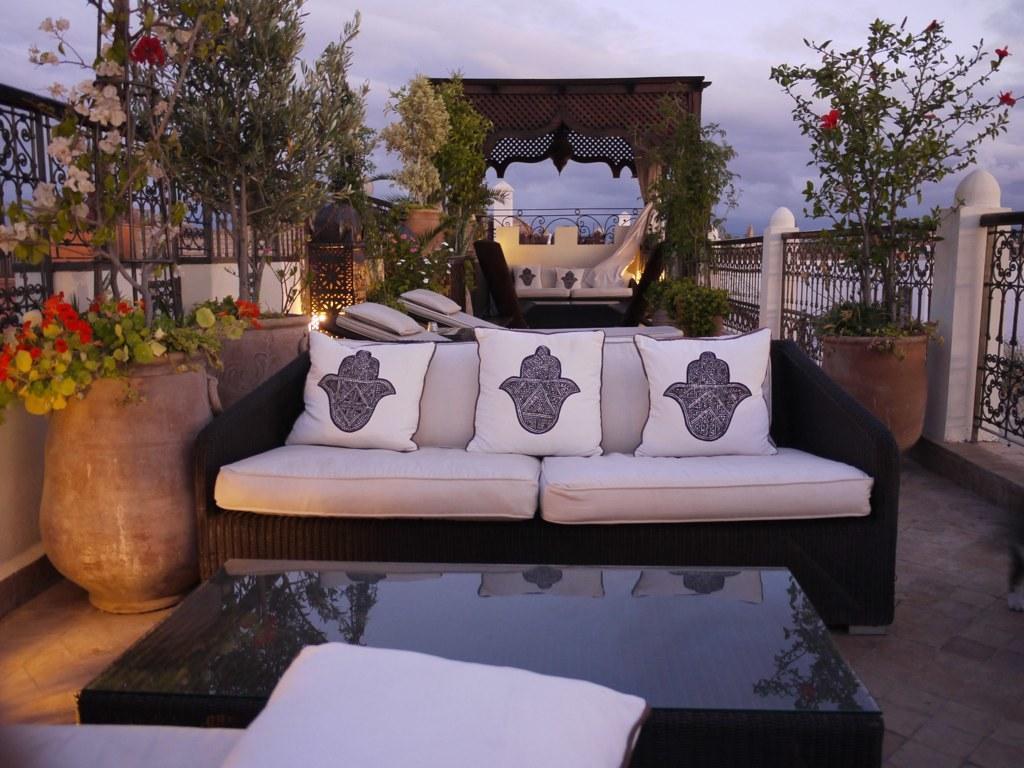Describe this image in one or two sentences. The picture is taken on a terrace. There is a sofa. In the middle there is a table. On the left there is a pot with plant. There is fence around the terrace. In the background there is a shelter like structure. Under that there is another sofa. The sky is cloudy. 